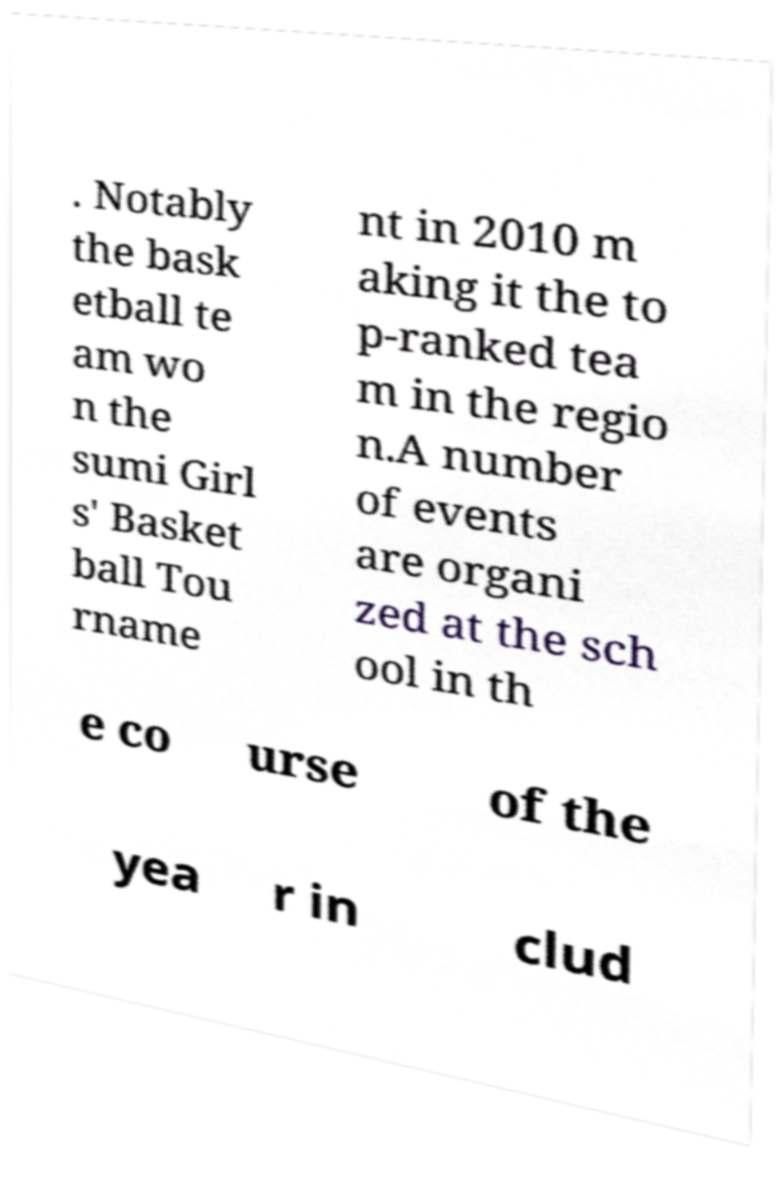I need the written content from this picture converted into text. Can you do that? . Notably the bask etball te am wo n the sumi Girl s' Basket ball Tou rname nt in 2010 m aking it the to p-ranked tea m in the regio n.A number of events are organi zed at the sch ool in th e co urse of the yea r in clud 